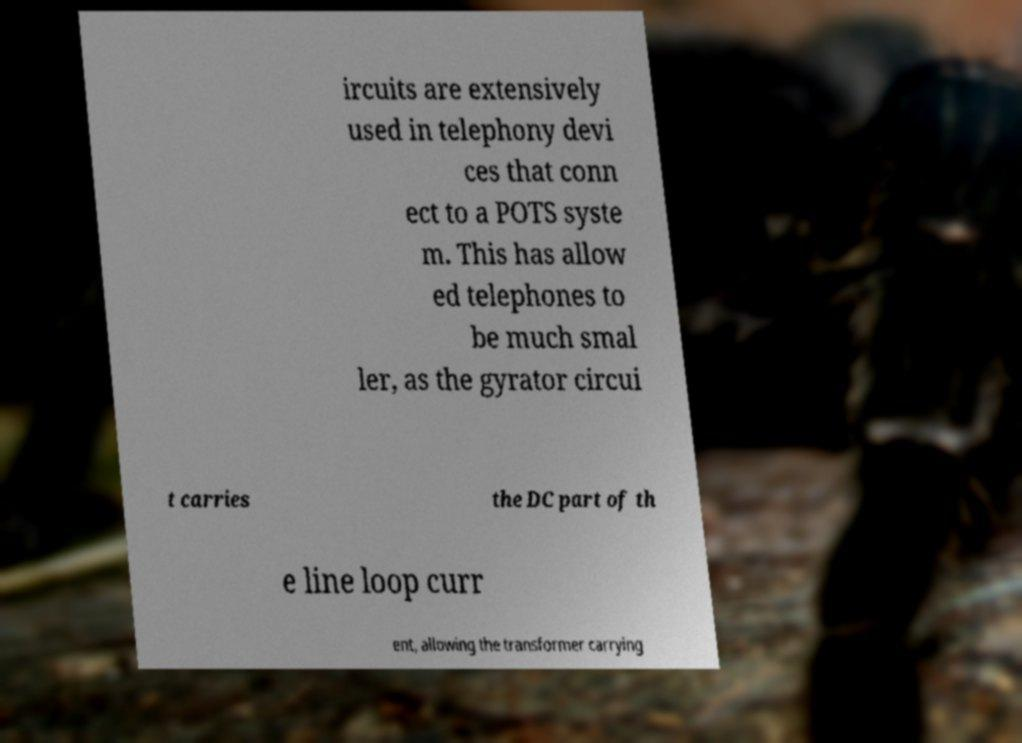Could you extract and type out the text from this image? ircuits are extensively used in telephony devi ces that conn ect to a POTS syste m. This has allow ed telephones to be much smal ler, as the gyrator circui t carries the DC part of th e line loop curr ent, allowing the transformer carrying 